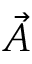<formula> <loc_0><loc_0><loc_500><loc_500>\vec { A }</formula> 